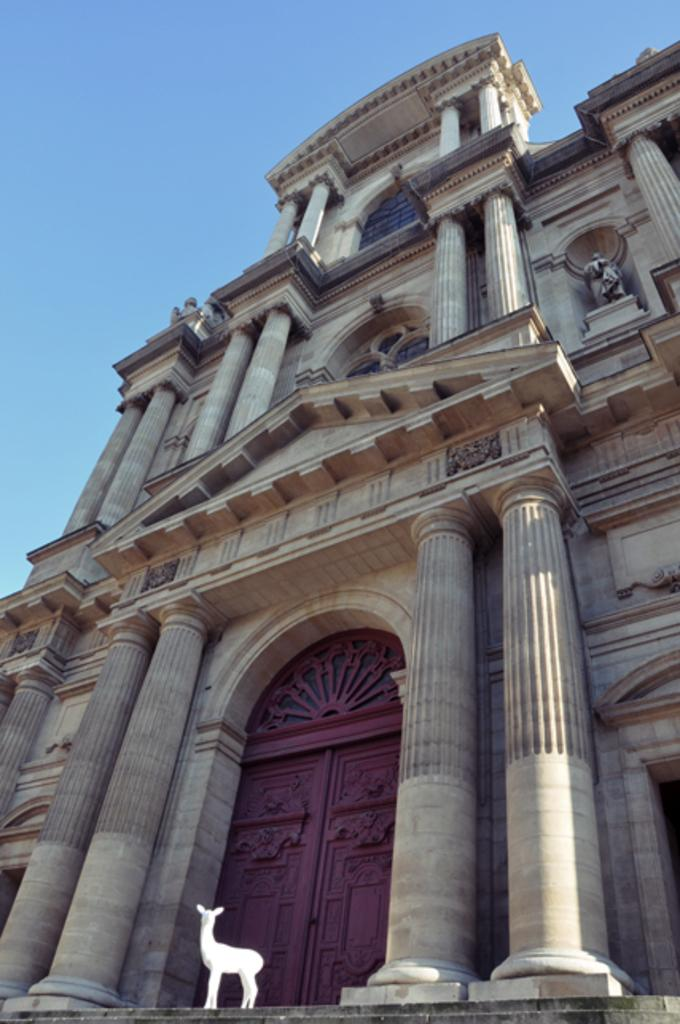What type of structure is present in the image? There is a building in the image. What features can be observed on the building? The building has windows, a door, and pillars. Is there any living creature visible in the image? Yes, there is an animal on the ground in the image. What can be seen in the sky in the image? The sky is visible at the top of the image. What type of button does the father in the image wear on his shirt? There is no father or button present in the image; it only features a building, an animal, and the sky. 